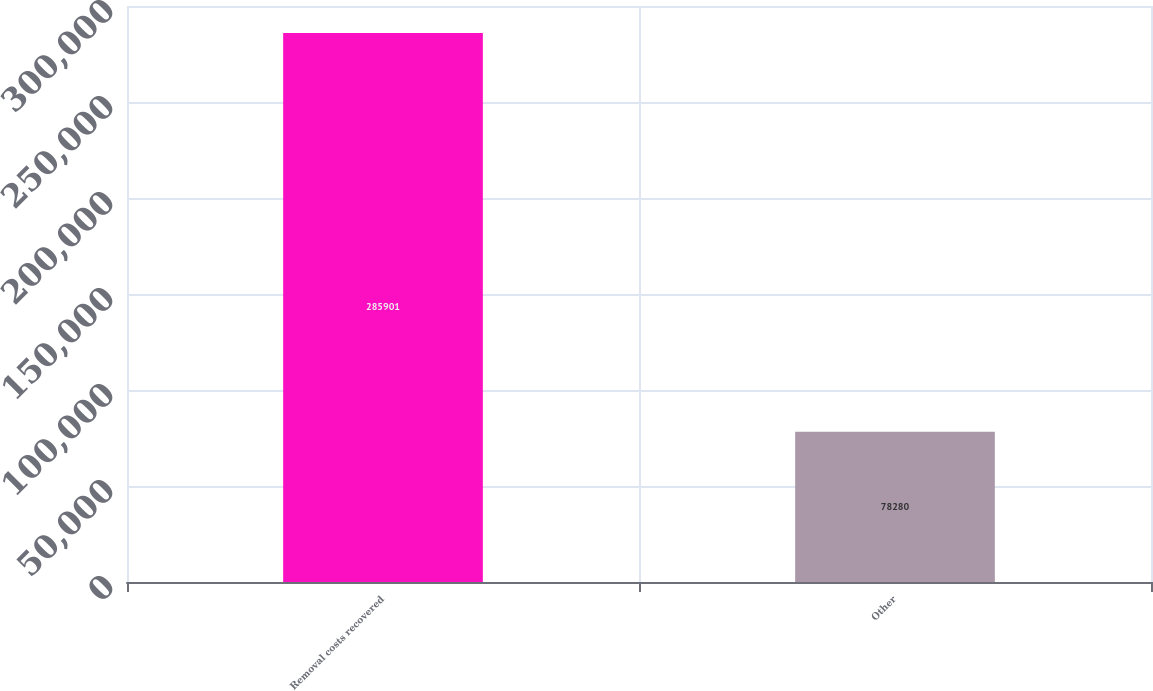Convert chart. <chart><loc_0><loc_0><loc_500><loc_500><bar_chart><fcel>Removal costs recovered<fcel>Other<nl><fcel>285901<fcel>78280<nl></chart> 